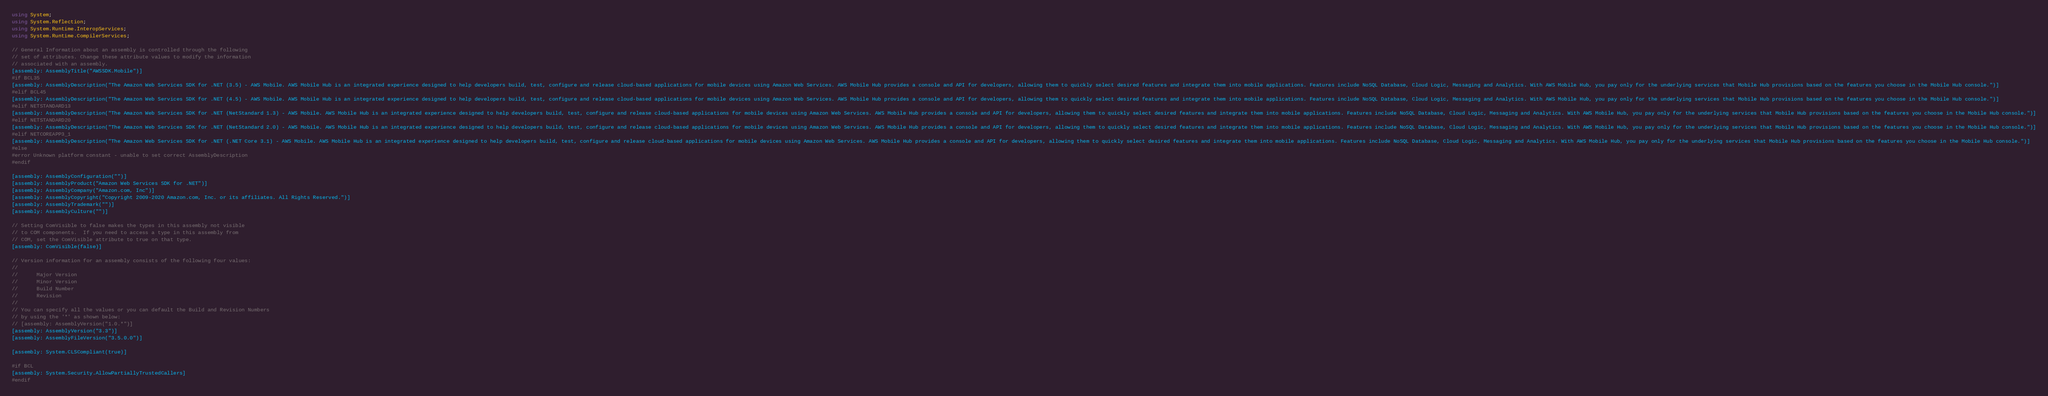Convert code to text. <code><loc_0><loc_0><loc_500><loc_500><_C#_>using System;
using System.Reflection;
using System.Runtime.InteropServices;
using System.Runtime.CompilerServices;

// General Information about an assembly is controlled through the following 
// set of attributes. Change these attribute values to modify the information
// associated with an assembly.
[assembly: AssemblyTitle("AWSSDK.Mobile")]
#if BCL35
[assembly: AssemblyDescription("The Amazon Web Services SDK for .NET (3.5) - AWS Mobile. AWS Mobile Hub is an integrated experience designed to help developers build, test, configure and release cloud-based applications for mobile devices using Amazon Web Services. AWS Mobile Hub provides a console and API for developers, allowing them to quickly select desired features and integrate them into mobile applications. Features include NoSQL Database, Cloud Logic, Messaging and Analytics. With AWS Mobile Hub, you pay only for the underlying services that Mobile Hub provisions based on the features you choose in the Mobile Hub console.")]
#elif BCL45
[assembly: AssemblyDescription("The Amazon Web Services SDK for .NET (4.5) - AWS Mobile. AWS Mobile Hub is an integrated experience designed to help developers build, test, configure and release cloud-based applications for mobile devices using Amazon Web Services. AWS Mobile Hub provides a console and API for developers, allowing them to quickly select desired features and integrate them into mobile applications. Features include NoSQL Database, Cloud Logic, Messaging and Analytics. With AWS Mobile Hub, you pay only for the underlying services that Mobile Hub provisions based on the features you choose in the Mobile Hub console.")]
#elif NETSTANDARD13
[assembly: AssemblyDescription("The Amazon Web Services SDK for .NET (NetStandard 1.3) - AWS Mobile. AWS Mobile Hub is an integrated experience designed to help developers build, test, configure and release cloud-based applications for mobile devices using Amazon Web Services. AWS Mobile Hub provides a console and API for developers, allowing them to quickly select desired features and integrate them into mobile applications. Features include NoSQL Database, Cloud Logic, Messaging and Analytics. With AWS Mobile Hub, you pay only for the underlying services that Mobile Hub provisions based on the features you choose in the Mobile Hub console.")]
#elif NETSTANDARD20
[assembly: AssemblyDescription("The Amazon Web Services SDK for .NET (NetStandard 2.0) - AWS Mobile. AWS Mobile Hub is an integrated experience designed to help developers build, test, configure and release cloud-based applications for mobile devices using Amazon Web Services. AWS Mobile Hub provides a console and API for developers, allowing them to quickly select desired features and integrate them into mobile applications. Features include NoSQL Database, Cloud Logic, Messaging and Analytics. With AWS Mobile Hub, you pay only for the underlying services that Mobile Hub provisions based on the features you choose in the Mobile Hub console.")]
#elif NETCOREAPP3_1
[assembly: AssemblyDescription("The Amazon Web Services SDK for .NET (.NET Core 3.1) - AWS Mobile. AWS Mobile Hub is an integrated experience designed to help developers build, test, configure and release cloud-based applications for mobile devices using Amazon Web Services. AWS Mobile Hub provides a console and API for developers, allowing them to quickly select desired features and integrate them into mobile applications. Features include NoSQL Database, Cloud Logic, Messaging and Analytics. With AWS Mobile Hub, you pay only for the underlying services that Mobile Hub provisions based on the features you choose in the Mobile Hub console.")]
#else
#error Unknown platform constant - unable to set correct AssemblyDescription
#endif

[assembly: AssemblyConfiguration("")]
[assembly: AssemblyProduct("Amazon Web Services SDK for .NET")]
[assembly: AssemblyCompany("Amazon.com, Inc")]
[assembly: AssemblyCopyright("Copyright 2009-2020 Amazon.com, Inc. or its affiliates. All Rights Reserved.")]
[assembly: AssemblyTrademark("")]
[assembly: AssemblyCulture("")]

// Setting ComVisible to false makes the types in this assembly not visible 
// to COM components.  If you need to access a type in this assembly from 
// COM, set the ComVisible attribute to true on that type.
[assembly: ComVisible(false)]

// Version information for an assembly consists of the following four values:
//
//      Major Version
//      Minor Version 
//      Build Number
//      Revision
//
// You can specify all the values or you can default the Build and Revision Numbers 
// by using the '*' as shown below:
// [assembly: AssemblyVersion("1.0.*")]
[assembly: AssemblyVersion("3.3")]
[assembly: AssemblyFileVersion("3.5.0.0")]

[assembly: System.CLSCompliant(true)]

#if BCL
[assembly: System.Security.AllowPartiallyTrustedCallers]
#endif</code> 